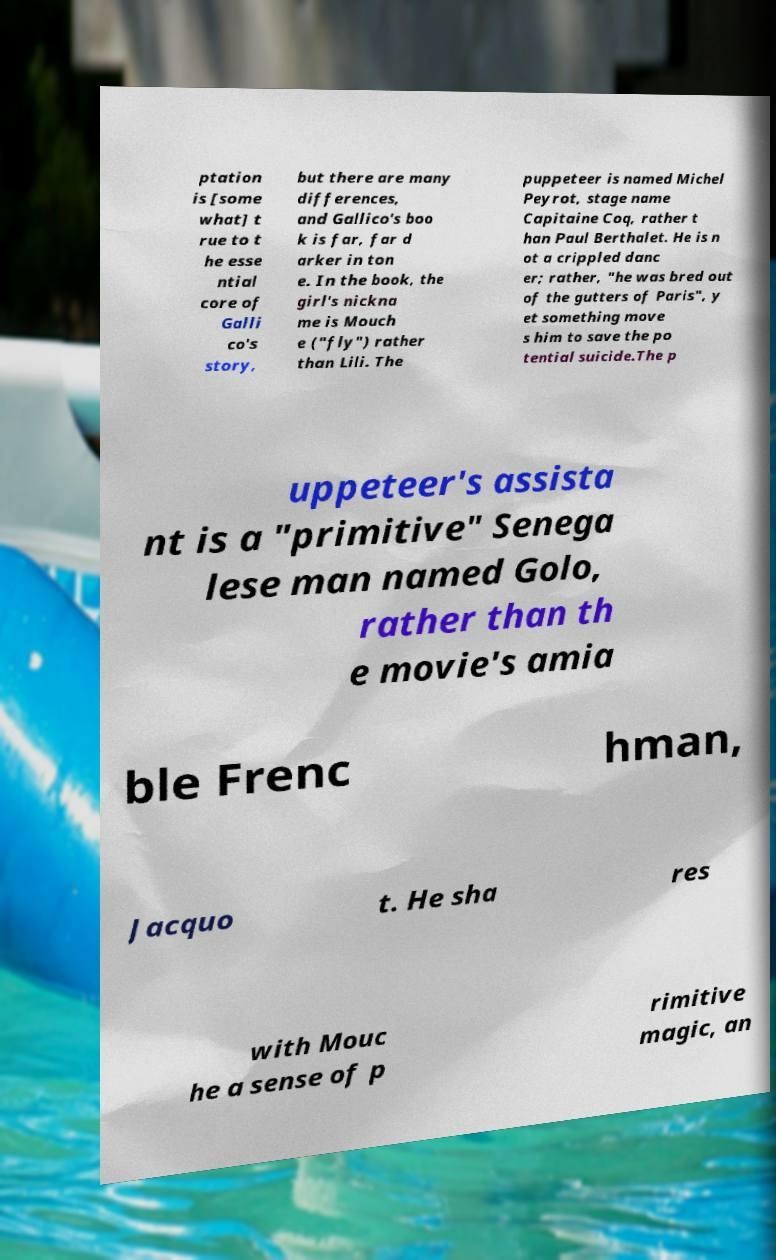What messages or text are displayed in this image? I need them in a readable, typed format. ptation is [some what] t rue to t he esse ntial core of Galli co's story, but there are many differences, and Gallico's boo k is far, far d arker in ton e. In the book, the girl's nickna me is Mouch e ("fly") rather than Lili. The puppeteer is named Michel Peyrot, stage name Capitaine Coq, rather t han Paul Berthalet. He is n ot a crippled danc er; rather, "he was bred out of the gutters of Paris", y et something move s him to save the po tential suicide.The p uppeteer's assista nt is a "primitive" Senega lese man named Golo, rather than th e movie's amia ble Frenc hman, Jacquo t. He sha res with Mouc he a sense of p rimitive magic, an 